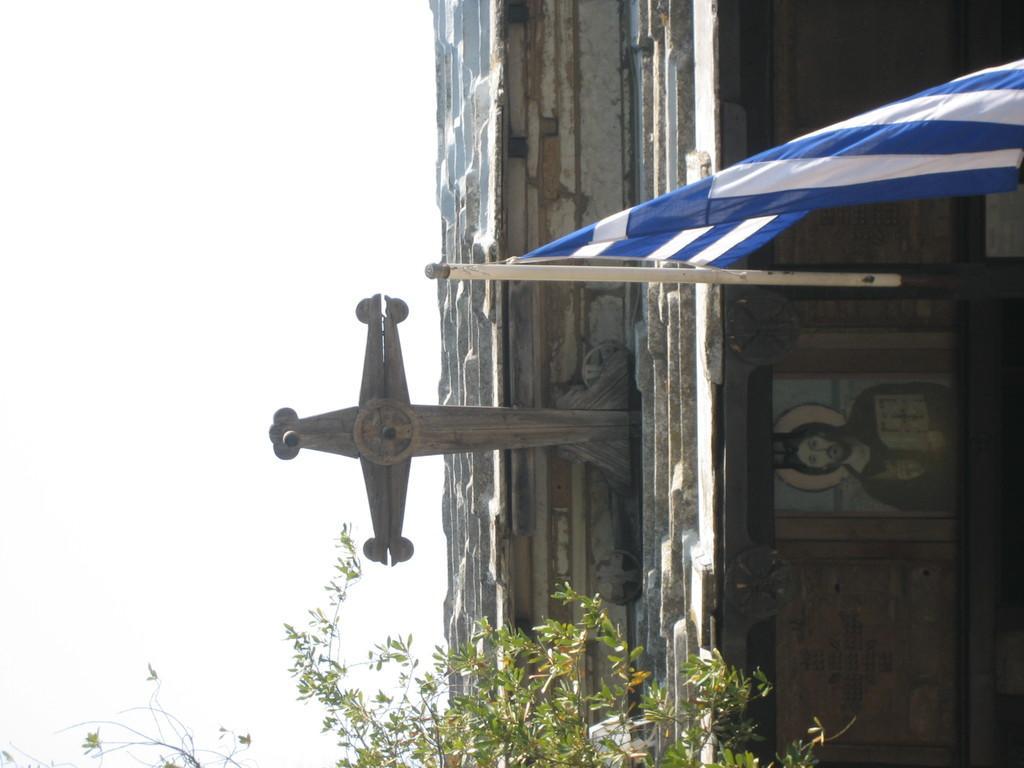Please provide a concise description of this image. This picture shows a cross on the house and we see a flag pole and a tree and we see a photo frame on the wall and a cloudy Sky. 